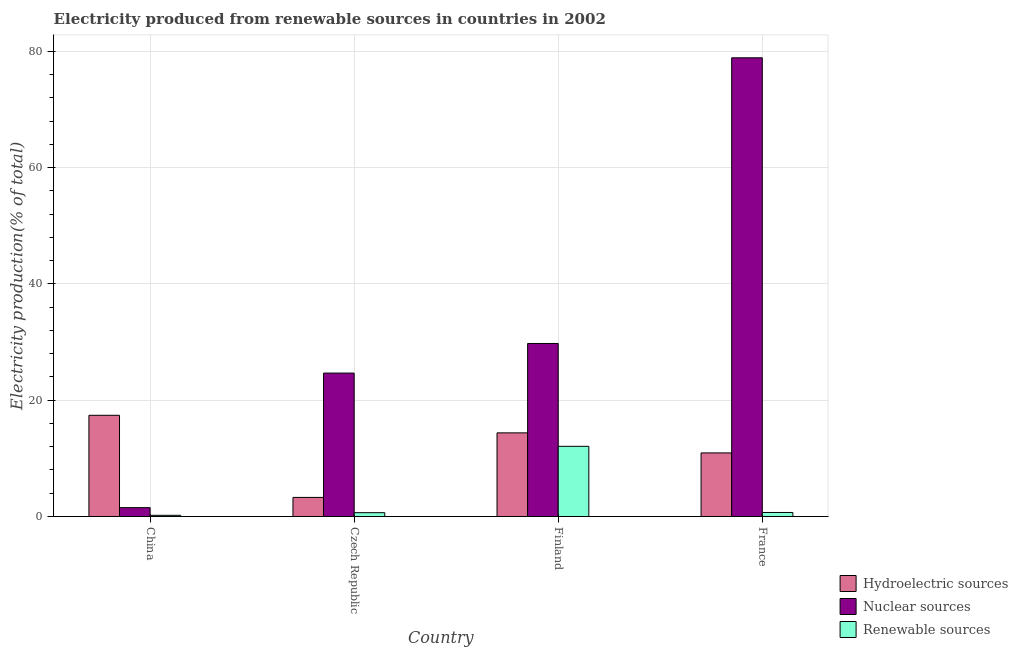How many different coloured bars are there?
Your answer should be very brief. 3. How many groups of bars are there?
Your answer should be very brief. 4. Are the number of bars per tick equal to the number of legend labels?
Your response must be concise. Yes. How many bars are there on the 3rd tick from the left?
Offer a terse response. 3. How many bars are there on the 3rd tick from the right?
Offer a terse response. 3. What is the label of the 2nd group of bars from the left?
Provide a short and direct response. Czech Republic. In how many cases, is the number of bars for a given country not equal to the number of legend labels?
Ensure brevity in your answer.  0. What is the percentage of electricity produced by hydroelectric sources in Czech Republic?
Make the answer very short. 3.28. Across all countries, what is the maximum percentage of electricity produced by renewable sources?
Give a very brief answer. 12.06. Across all countries, what is the minimum percentage of electricity produced by renewable sources?
Keep it short and to the point. 0.2. In which country was the percentage of electricity produced by hydroelectric sources maximum?
Offer a very short reply. China. In which country was the percentage of electricity produced by hydroelectric sources minimum?
Your answer should be compact. Czech Republic. What is the total percentage of electricity produced by nuclear sources in the graph?
Ensure brevity in your answer.  134.79. What is the difference between the percentage of electricity produced by nuclear sources in China and that in Czech Republic?
Make the answer very short. -23.14. What is the difference between the percentage of electricity produced by hydroelectric sources in China and the percentage of electricity produced by nuclear sources in France?
Ensure brevity in your answer.  -61.47. What is the average percentage of electricity produced by nuclear sources per country?
Ensure brevity in your answer.  33.7. What is the difference between the percentage of electricity produced by hydroelectric sources and percentage of electricity produced by nuclear sources in Czech Republic?
Ensure brevity in your answer.  -21.38. In how many countries, is the percentage of electricity produced by renewable sources greater than 44 %?
Your answer should be very brief. 0. What is the ratio of the percentage of electricity produced by renewable sources in Czech Republic to that in France?
Provide a short and direct response. 0.95. What is the difference between the highest and the second highest percentage of electricity produced by hydroelectric sources?
Keep it short and to the point. 3.02. What is the difference between the highest and the lowest percentage of electricity produced by renewable sources?
Offer a terse response. 11.86. In how many countries, is the percentage of electricity produced by nuclear sources greater than the average percentage of electricity produced by nuclear sources taken over all countries?
Your answer should be compact. 1. Is the sum of the percentage of electricity produced by nuclear sources in Czech Republic and Finland greater than the maximum percentage of electricity produced by renewable sources across all countries?
Your answer should be compact. Yes. What does the 3rd bar from the left in Finland represents?
Provide a succinct answer. Renewable sources. What does the 2nd bar from the right in France represents?
Offer a terse response. Nuclear sources. How many bars are there?
Keep it short and to the point. 12. Are all the bars in the graph horizontal?
Provide a succinct answer. No. How many countries are there in the graph?
Keep it short and to the point. 4. What is the difference between two consecutive major ticks on the Y-axis?
Offer a terse response. 20. Does the graph contain any zero values?
Ensure brevity in your answer.  No. Where does the legend appear in the graph?
Make the answer very short. Bottom right. How are the legend labels stacked?
Provide a succinct answer. Vertical. What is the title of the graph?
Provide a succinct answer. Electricity produced from renewable sources in countries in 2002. What is the label or title of the X-axis?
Provide a succinct answer. Country. What is the Electricity production(% of total) in Hydroelectric sources in China?
Ensure brevity in your answer.  17.4. What is the Electricity production(% of total) of Nuclear sources in China?
Give a very brief answer. 1.52. What is the Electricity production(% of total) of Renewable sources in China?
Offer a very short reply. 0.2. What is the Electricity production(% of total) in Hydroelectric sources in Czech Republic?
Provide a succinct answer. 3.28. What is the Electricity production(% of total) of Nuclear sources in Czech Republic?
Offer a terse response. 24.66. What is the Electricity production(% of total) of Renewable sources in Czech Republic?
Your answer should be compact. 0.66. What is the Electricity production(% of total) of Hydroelectric sources in Finland?
Your answer should be compact. 14.38. What is the Electricity production(% of total) in Nuclear sources in Finland?
Provide a succinct answer. 29.75. What is the Electricity production(% of total) in Renewable sources in Finland?
Keep it short and to the point. 12.06. What is the Electricity production(% of total) in Hydroelectric sources in France?
Your answer should be compact. 10.93. What is the Electricity production(% of total) in Nuclear sources in France?
Your answer should be very brief. 78.87. What is the Electricity production(% of total) in Renewable sources in France?
Ensure brevity in your answer.  0.69. Across all countries, what is the maximum Electricity production(% of total) in Hydroelectric sources?
Offer a terse response. 17.4. Across all countries, what is the maximum Electricity production(% of total) in Nuclear sources?
Offer a terse response. 78.87. Across all countries, what is the maximum Electricity production(% of total) in Renewable sources?
Offer a very short reply. 12.06. Across all countries, what is the minimum Electricity production(% of total) in Hydroelectric sources?
Your answer should be compact. 3.28. Across all countries, what is the minimum Electricity production(% of total) in Nuclear sources?
Keep it short and to the point. 1.52. Across all countries, what is the minimum Electricity production(% of total) in Renewable sources?
Make the answer very short. 0.2. What is the total Electricity production(% of total) in Hydroelectric sources in the graph?
Keep it short and to the point. 45.99. What is the total Electricity production(% of total) of Nuclear sources in the graph?
Provide a short and direct response. 134.79. What is the total Electricity production(% of total) in Renewable sources in the graph?
Your response must be concise. 13.61. What is the difference between the Electricity production(% of total) of Hydroelectric sources in China and that in Czech Republic?
Keep it short and to the point. 14.12. What is the difference between the Electricity production(% of total) of Nuclear sources in China and that in Czech Republic?
Give a very brief answer. -23.14. What is the difference between the Electricity production(% of total) in Renewable sources in China and that in Czech Republic?
Give a very brief answer. -0.45. What is the difference between the Electricity production(% of total) of Hydroelectric sources in China and that in Finland?
Offer a terse response. 3.02. What is the difference between the Electricity production(% of total) in Nuclear sources in China and that in Finland?
Give a very brief answer. -28.23. What is the difference between the Electricity production(% of total) in Renewable sources in China and that in Finland?
Offer a terse response. -11.86. What is the difference between the Electricity production(% of total) of Hydroelectric sources in China and that in France?
Provide a succinct answer. 6.47. What is the difference between the Electricity production(% of total) in Nuclear sources in China and that in France?
Ensure brevity in your answer.  -77.35. What is the difference between the Electricity production(% of total) of Renewable sources in China and that in France?
Provide a succinct answer. -0.49. What is the difference between the Electricity production(% of total) of Hydroelectric sources in Czech Republic and that in Finland?
Provide a succinct answer. -11.1. What is the difference between the Electricity production(% of total) in Nuclear sources in Czech Republic and that in Finland?
Your response must be concise. -5.09. What is the difference between the Electricity production(% of total) in Renewable sources in Czech Republic and that in Finland?
Provide a succinct answer. -11.41. What is the difference between the Electricity production(% of total) in Hydroelectric sources in Czech Republic and that in France?
Your answer should be compact. -7.65. What is the difference between the Electricity production(% of total) in Nuclear sources in Czech Republic and that in France?
Give a very brief answer. -54.21. What is the difference between the Electricity production(% of total) in Renewable sources in Czech Republic and that in France?
Offer a terse response. -0.03. What is the difference between the Electricity production(% of total) in Hydroelectric sources in Finland and that in France?
Make the answer very short. 3.45. What is the difference between the Electricity production(% of total) of Nuclear sources in Finland and that in France?
Provide a succinct answer. -49.12. What is the difference between the Electricity production(% of total) in Renewable sources in Finland and that in France?
Offer a very short reply. 11.38. What is the difference between the Electricity production(% of total) of Hydroelectric sources in China and the Electricity production(% of total) of Nuclear sources in Czech Republic?
Your response must be concise. -7.26. What is the difference between the Electricity production(% of total) in Hydroelectric sources in China and the Electricity production(% of total) in Renewable sources in Czech Republic?
Offer a very short reply. 16.75. What is the difference between the Electricity production(% of total) of Nuclear sources in China and the Electricity production(% of total) of Renewable sources in Czech Republic?
Keep it short and to the point. 0.86. What is the difference between the Electricity production(% of total) of Hydroelectric sources in China and the Electricity production(% of total) of Nuclear sources in Finland?
Offer a very short reply. -12.35. What is the difference between the Electricity production(% of total) in Hydroelectric sources in China and the Electricity production(% of total) in Renewable sources in Finland?
Make the answer very short. 5.34. What is the difference between the Electricity production(% of total) of Nuclear sources in China and the Electricity production(% of total) of Renewable sources in Finland?
Your response must be concise. -10.55. What is the difference between the Electricity production(% of total) of Hydroelectric sources in China and the Electricity production(% of total) of Nuclear sources in France?
Your answer should be very brief. -61.47. What is the difference between the Electricity production(% of total) of Hydroelectric sources in China and the Electricity production(% of total) of Renewable sources in France?
Your answer should be very brief. 16.71. What is the difference between the Electricity production(% of total) in Nuclear sources in China and the Electricity production(% of total) in Renewable sources in France?
Your response must be concise. 0.83. What is the difference between the Electricity production(% of total) in Hydroelectric sources in Czech Republic and the Electricity production(% of total) in Nuclear sources in Finland?
Provide a short and direct response. -26.47. What is the difference between the Electricity production(% of total) in Hydroelectric sources in Czech Republic and the Electricity production(% of total) in Renewable sources in Finland?
Give a very brief answer. -8.79. What is the difference between the Electricity production(% of total) of Nuclear sources in Czech Republic and the Electricity production(% of total) of Renewable sources in Finland?
Your response must be concise. 12.59. What is the difference between the Electricity production(% of total) of Hydroelectric sources in Czech Republic and the Electricity production(% of total) of Nuclear sources in France?
Your answer should be compact. -75.59. What is the difference between the Electricity production(% of total) of Hydroelectric sources in Czech Republic and the Electricity production(% of total) of Renewable sources in France?
Keep it short and to the point. 2.59. What is the difference between the Electricity production(% of total) of Nuclear sources in Czech Republic and the Electricity production(% of total) of Renewable sources in France?
Your answer should be compact. 23.97. What is the difference between the Electricity production(% of total) in Hydroelectric sources in Finland and the Electricity production(% of total) in Nuclear sources in France?
Your answer should be very brief. -64.49. What is the difference between the Electricity production(% of total) of Hydroelectric sources in Finland and the Electricity production(% of total) of Renewable sources in France?
Provide a short and direct response. 13.69. What is the difference between the Electricity production(% of total) of Nuclear sources in Finland and the Electricity production(% of total) of Renewable sources in France?
Offer a very short reply. 29.06. What is the average Electricity production(% of total) of Hydroelectric sources per country?
Your answer should be compact. 11.5. What is the average Electricity production(% of total) of Nuclear sources per country?
Offer a very short reply. 33.7. What is the average Electricity production(% of total) of Renewable sources per country?
Your answer should be compact. 3.4. What is the difference between the Electricity production(% of total) in Hydroelectric sources and Electricity production(% of total) in Nuclear sources in China?
Offer a terse response. 15.88. What is the difference between the Electricity production(% of total) in Hydroelectric sources and Electricity production(% of total) in Renewable sources in China?
Make the answer very short. 17.2. What is the difference between the Electricity production(% of total) of Nuclear sources and Electricity production(% of total) of Renewable sources in China?
Your response must be concise. 1.32. What is the difference between the Electricity production(% of total) of Hydroelectric sources and Electricity production(% of total) of Nuclear sources in Czech Republic?
Keep it short and to the point. -21.38. What is the difference between the Electricity production(% of total) in Hydroelectric sources and Electricity production(% of total) in Renewable sources in Czech Republic?
Keep it short and to the point. 2.62. What is the difference between the Electricity production(% of total) of Nuclear sources and Electricity production(% of total) of Renewable sources in Czech Republic?
Ensure brevity in your answer.  24. What is the difference between the Electricity production(% of total) in Hydroelectric sources and Electricity production(% of total) in Nuclear sources in Finland?
Offer a very short reply. -15.37. What is the difference between the Electricity production(% of total) of Hydroelectric sources and Electricity production(% of total) of Renewable sources in Finland?
Make the answer very short. 2.31. What is the difference between the Electricity production(% of total) in Nuclear sources and Electricity production(% of total) in Renewable sources in Finland?
Offer a terse response. 17.68. What is the difference between the Electricity production(% of total) in Hydroelectric sources and Electricity production(% of total) in Nuclear sources in France?
Make the answer very short. -67.94. What is the difference between the Electricity production(% of total) of Hydroelectric sources and Electricity production(% of total) of Renewable sources in France?
Make the answer very short. 10.24. What is the difference between the Electricity production(% of total) in Nuclear sources and Electricity production(% of total) in Renewable sources in France?
Your response must be concise. 78.18. What is the ratio of the Electricity production(% of total) in Hydroelectric sources in China to that in Czech Republic?
Your response must be concise. 5.31. What is the ratio of the Electricity production(% of total) in Nuclear sources in China to that in Czech Republic?
Provide a succinct answer. 0.06. What is the ratio of the Electricity production(% of total) in Renewable sources in China to that in Czech Republic?
Provide a succinct answer. 0.31. What is the ratio of the Electricity production(% of total) in Hydroelectric sources in China to that in Finland?
Offer a terse response. 1.21. What is the ratio of the Electricity production(% of total) of Nuclear sources in China to that in Finland?
Your response must be concise. 0.05. What is the ratio of the Electricity production(% of total) in Renewable sources in China to that in Finland?
Offer a terse response. 0.02. What is the ratio of the Electricity production(% of total) in Hydroelectric sources in China to that in France?
Your answer should be compact. 1.59. What is the ratio of the Electricity production(% of total) of Nuclear sources in China to that in France?
Keep it short and to the point. 0.02. What is the ratio of the Electricity production(% of total) of Renewable sources in China to that in France?
Give a very brief answer. 0.29. What is the ratio of the Electricity production(% of total) in Hydroelectric sources in Czech Republic to that in Finland?
Provide a succinct answer. 0.23. What is the ratio of the Electricity production(% of total) of Nuclear sources in Czech Republic to that in Finland?
Provide a short and direct response. 0.83. What is the ratio of the Electricity production(% of total) of Renewable sources in Czech Republic to that in Finland?
Your answer should be very brief. 0.05. What is the ratio of the Electricity production(% of total) of Hydroelectric sources in Czech Republic to that in France?
Offer a very short reply. 0.3. What is the ratio of the Electricity production(% of total) in Nuclear sources in Czech Republic to that in France?
Your answer should be compact. 0.31. What is the ratio of the Electricity production(% of total) in Renewable sources in Czech Republic to that in France?
Your response must be concise. 0.95. What is the ratio of the Electricity production(% of total) in Hydroelectric sources in Finland to that in France?
Provide a short and direct response. 1.32. What is the ratio of the Electricity production(% of total) of Nuclear sources in Finland to that in France?
Provide a short and direct response. 0.38. What is the ratio of the Electricity production(% of total) of Renewable sources in Finland to that in France?
Ensure brevity in your answer.  17.52. What is the difference between the highest and the second highest Electricity production(% of total) in Hydroelectric sources?
Ensure brevity in your answer.  3.02. What is the difference between the highest and the second highest Electricity production(% of total) in Nuclear sources?
Make the answer very short. 49.12. What is the difference between the highest and the second highest Electricity production(% of total) of Renewable sources?
Your answer should be compact. 11.38. What is the difference between the highest and the lowest Electricity production(% of total) of Hydroelectric sources?
Offer a very short reply. 14.12. What is the difference between the highest and the lowest Electricity production(% of total) of Nuclear sources?
Offer a terse response. 77.35. What is the difference between the highest and the lowest Electricity production(% of total) in Renewable sources?
Provide a short and direct response. 11.86. 